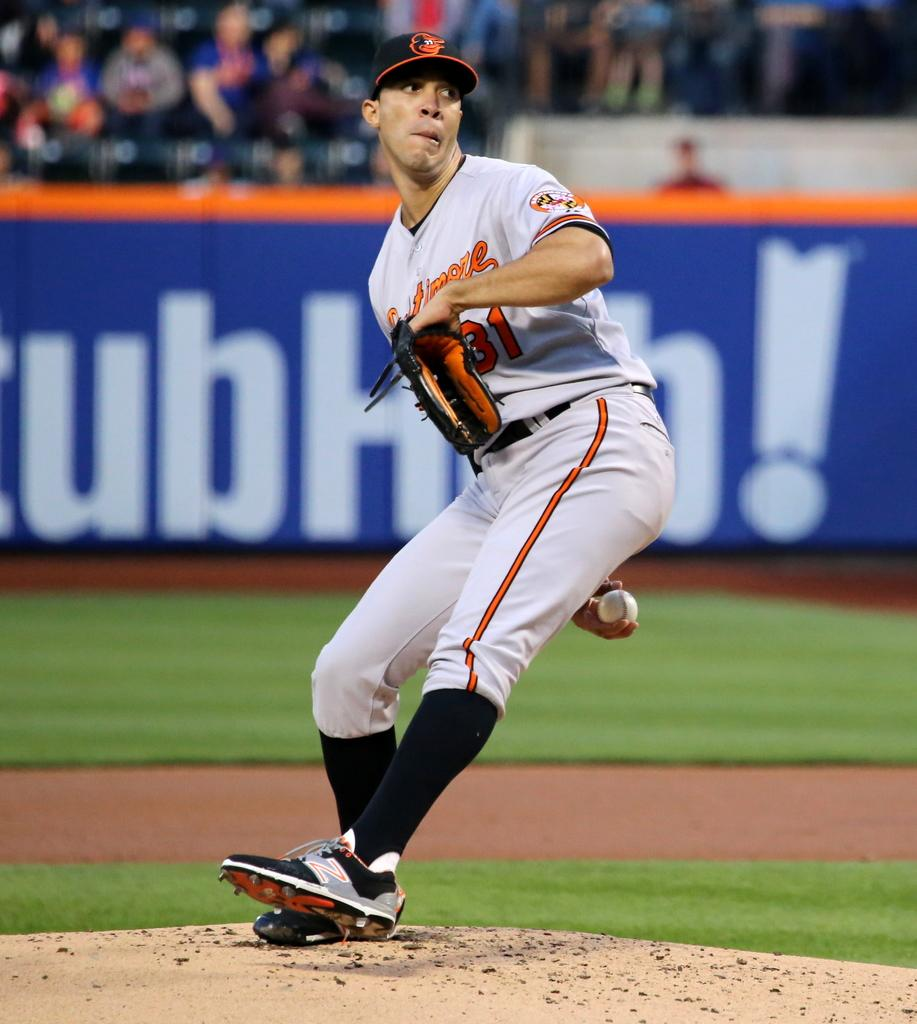Provide a one-sentence caption for the provided image. A pitcher on the mound of a baseball field is about to throw the ball with a StubHub advertisement visible in the background. 